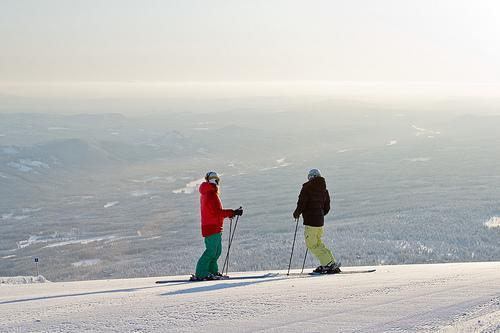How many people are shown?
Give a very brief answer. 2. 